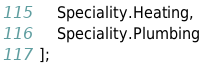<code> <loc_0><loc_0><loc_500><loc_500><_TypeScript_>    Speciality.Heating,
    Speciality.Plumbing
];</code> 